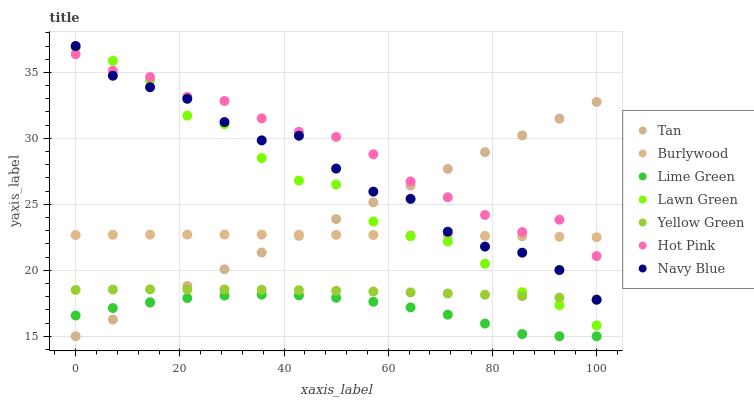Does Lime Green have the minimum area under the curve?
Answer yes or no. Yes. Does Hot Pink have the maximum area under the curve?
Answer yes or no. Yes. Does Yellow Green have the minimum area under the curve?
Answer yes or no. No. Does Yellow Green have the maximum area under the curve?
Answer yes or no. No. Is Tan the smoothest?
Answer yes or no. Yes. Is Lawn Green the roughest?
Answer yes or no. Yes. Is Yellow Green the smoothest?
Answer yes or no. No. Is Yellow Green the roughest?
Answer yes or no. No. Does Tan have the lowest value?
Answer yes or no. Yes. Does Yellow Green have the lowest value?
Answer yes or no. No. Does Navy Blue have the highest value?
Answer yes or no. Yes. Does Yellow Green have the highest value?
Answer yes or no. No. Is Yellow Green less than Hot Pink?
Answer yes or no. Yes. Is Burlywood greater than Yellow Green?
Answer yes or no. Yes. Does Lawn Green intersect Yellow Green?
Answer yes or no. Yes. Is Lawn Green less than Yellow Green?
Answer yes or no. No. Is Lawn Green greater than Yellow Green?
Answer yes or no. No. Does Yellow Green intersect Hot Pink?
Answer yes or no. No. 